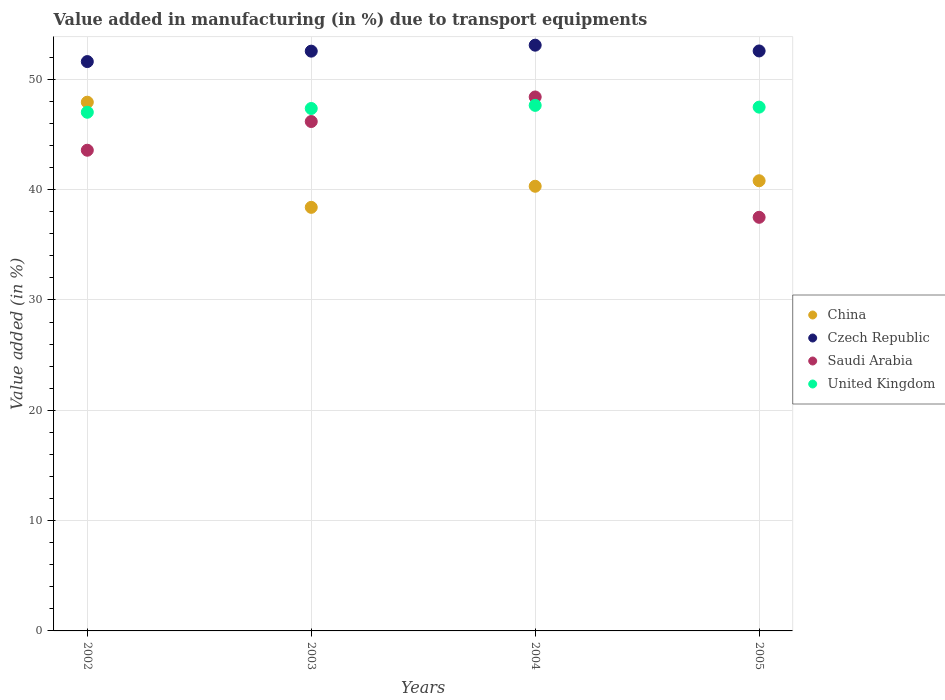How many different coloured dotlines are there?
Give a very brief answer. 4. Is the number of dotlines equal to the number of legend labels?
Offer a terse response. Yes. What is the percentage of value added in manufacturing due to transport equipments in China in 2005?
Ensure brevity in your answer.  40.81. Across all years, what is the maximum percentage of value added in manufacturing due to transport equipments in China?
Your answer should be very brief. 47.93. Across all years, what is the minimum percentage of value added in manufacturing due to transport equipments in Saudi Arabia?
Your response must be concise. 37.49. In which year was the percentage of value added in manufacturing due to transport equipments in Saudi Arabia minimum?
Give a very brief answer. 2005. What is the total percentage of value added in manufacturing due to transport equipments in Czech Republic in the graph?
Your response must be concise. 209.84. What is the difference between the percentage of value added in manufacturing due to transport equipments in Czech Republic in 2003 and that in 2005?
Keep it short and to the point. -0.02. What is the difference between the percentage of value added in manufacturing due to transport equipments in China in 2003 and the percentage of value added in manufacturing due to transport equipments in United Kingdom in 2005?
Give a very brief answer. -9.08. What is the average percentage of value added in manufacturing due to transport equipments in United Kingdom per year?
Keep it short and to the point. 47.37. In the year 2003, what is the difference between the percentage of value added in manufacturing due to transport equipments in United Kingdom and percentage of value added in manufacturing due to transport equipments in Saudi Arabia?
Give a very brief answer. 1.18. In how many years, is the percentage of value added in manufacturing due to transport equipments in Czech Republic greater than 32 %?
Offer a very short reply. 4. What is the ratio of the percentage of value added in manufacturing due to transport equipments in China in 2002 to that in 2005?
Offer a very short reply. 1.17. Is the difference between the percentage of value added in manufacturing due to transport equipments in United Kingdom in 2002 and 2005 greater than the difference between the percentage of value added in manufacturing due to transport equipments in Saudi Arabia in 2002 and 2005?
Provide a short and direct response. No. What is the difference between the highest and the second highest percentage of value added in manufacturing due to transport equipments in China?
Make the answer very short. 7.12. What is the difference between the highest and the lowest percentage of value added in manufacturing due to transport equipments in China?
Provide a succinct answer. 9.53. Is the sum of the percentage of value added in manufacturing due to transport equipments in China in 2004 and 2005 greater than the maximum percentage of value added in manufacturing due to transport equipments in United Kingdom across all years?
Make the answer very short. Yes. Does the percentage of value added in manufacturing due to transport equipments in China monotonically increase over the years?
Offer a very short reply. No. Is the percentage of value added in manufacturing due to transport equipments in China strictly less than the percentage of value added in manufacturing due to transport equipments in Czech Republic over the years?
Provide a short and direct response. Yes. How many years are there in the graph?
Offer a very short reply. 4. Does the graph contain any zero values?
Give a very brief answer. No. How many legend labels are there?
Make the answer very short. 4. How are the legend labels stacked?
Your response must be concise. Vertical. What is the title of the graph?
Make the answer very short. Value added in manufacturing (in %) due to transport equipments. Does "Seychelles" appear as one of the legend labels in the graph?
Your answer should be compact. No. What is the label or title of the Y-axis?
Provide a succinct answer. Value added (in %). What is the Value added (in %) of China in 2002?
Provide a short and direct response. 47.93. What is the Value added (in %) of Czech Republic in 2002?
Offer a terse response. 51.61. What is the Value added (in %) in Saudi Arabia in 2002?
Provide a succinct answer. 43.57. What is the Value added (in %) in United Kingdom in 2002?
Offer a very short reply. 47.02. What is the Value added (in %) in China in 2003?
Your response must be concise. 38.4. What is the Value added (in %) of Czech Republic in 2003?
Offer a terse response. 52.56. What is the Value added (in %) of Saudi Arabia in 2003?
Keep it short and to the point. 46.18. What is the Value added (in %) of United Kingdom in 2003?
Ensure brevity in your answer.  47.36. What is the Value added (in %) in China in 2004?
Your answer should be very brief. 40.31. What is the Value added (in %) in Czech Republic in 2004?
Ensure brevity in your answer.  53.1. What is the Value added (in %) of Saudi Arabia in 2004?
Offer a very short reply. 48.4. What is the Value added (in %) in United Kingdom in 2004?
Your answer should be very brief. 47.64. What is the Value added (in %) of China in 2005?
Your response must be concise. 40.81. What is the Value added (in %) of Czech Republic in 2005?
Ensure brevity in your answer.  52.57. What is the Value added (in %) of Saudi Arabia in 2005?
Offer a very short reply. 37.49. What is the Value added (in %) of United Kingdom in 2005?
Ensure brevity in your answer.  47.48. Across all years, what is the maximum Value added (in %) in China?
Provide a succinct answer. 47.93. Across all years, what is the maximum Value added (in %) in Czech Republic?
Provide a succinct answer. 53.1. Across all years, what is the maximum Value added (in %) in Saudi Arabia?
Provide a succinct answer. 48.4. Across all years, what is the maximum Value added (in %) of United Kingdom?
Keep it short and to the point. 47.64. Across all years, what is the minimum Value added (in %) in China?
Your answer should be compact. 38.4. Across all years, what is the minimum Value added (in %) of Czech Republic?
Give a very brief answer. 51.61. Across all years, what is the minimum Value added (in %) in Saudi Arabia?
Your response must be concise. 37.49. Across all years, what is the minimum Value added (in %) of United Kingdom?
Give a very brief answer. 47.02. What is the total Value added (in %) in China in the graph?
Offer a very short reply. 167.44. What is the total Value added (in %) in Czech Republic in the graph?
Provide a succinct answer. 209.84. What is the total Value added (in %) of Saudi Arabia in the graph?
Your answer should be very brief. 175.65. What is the total Value added (in %) in United Kingdom in the graph?
Your answer should be compact. 189.49. What is the difference between the Value added (in %) of China in 2002 and that in 2003?
Provide a succinct answer. 9.53. What is the difference between the Value added (in %) of Czech Republic in 2002 and that in 2003?
Your answer should be compact. -0.95. What is the difference between the Value added (in %) in Saudi Arabia in 2002 and that in 2003?
Make the answer very short. -2.6. What is the difference between the Value added (in %) in United Kingdom in 2002 and that in 2003?
Provide a succinct answer. -0.34. What is the difference between the Value added (in %) of China in 2002 and that in 2004?
Offer a terse response. 7.62. What is the difference between the Value added (in %) in Czech Republic in 2002 and that in 2004?
Your answer should be very brief. -1.49. What is the difference between the Value added (in %) in Saudi Arabia in 2002 and that in 2004?
Offer a terse response. -4.83. What is the difference between the Value added (in %) in United Kingdom in 2002 and that in 2004?
Provide a short and direct response. -0.62. What is the difference between the Value added (in %) of China in 2002 and that in 2005?
Provide a succinct answer. 7.12. What is the difference between the Value added (in %) of Czech Republic in 2002 and that in 2005?
Provide a short and direct response. -0.96. What is the difference between the Value added (in %) of Saudi Arabia in 2002 and that in 2005?
Provide a short and direct response. 6.08. What is the difference between the Value added (in %) of United Kingdom in 2002 and that in 2005?
Provide a succinct answer. -0.46. What is the difference between the Value added (in %) of China in 2003 and that in 2004?
Make the answer very short. -1.91. What is the difference between the Value added (in %) of Czech Republic in 2003 and that in 2004?
Provide a short and direct response. -0.54. What is the difference between the Value added (in %) in Saudi Arabia in 2003 and that in 2004?
Make the answer very short. -2.23. What is the difference between the Value added (in %) of United Kingdom in 2003 and that in 2004?
Provide a succinct answer. -0.28. What is the difference between the Value added (in %) in China in 2003 and that in 2005?
Provide a short and direct response. -2.41. What is the difference between the Value added (in %) in Czech Republic in 2003 and that in 2005?
Offer a terse response. -0.02. What is the difference between the Value added (in %) of Saudi Arabia in 2003 and that in 2005?
Ensure brevity in your answer.  8.68. What is the difference between the Value added (in %) in United Kingdom in 2003 and that in 2005?
Give a very brief answer. -0.12. What is the difference between the Value added (in %) in China in 2004 and that in 2005?
Ensure brevity in your answer.  -0.5. What is the difference between the Value added (in %) of Czech Republic in 2004 and that in 2005?
Your response must be concise. 0.52. What is the difference between the Value added (in %) in Saudi Arabia in 2004 and that in 2005?
Your answer should be very brief. 10.91. What is the difference between the Value added (in %) in United Kingdom in 2004 and that in 2005?
Your answer should be compact. 0.16. What is the difference between the Value added (in %) of China in 2002 and the Value added (in %) of Czech Republic in 2003?
Provide a succinct answer. -4.63. What is the difference between the Value added (in %) in China in 2002 and the Value added (in %) in Saudi Arabia in 2003?
Your response must be concise. 1.75. What is the difference between the Value added (in %) in China in 2002 and the Value added (in %) in United Kingdom in 2003?
Provide a short and direct response. 0.57. What is the difference between the Value added (in %) of Czech Republic in 2002 and the Value added (in %) of Saudi Arabia in 2003?
Offer a very short reply. 5.43. What is the difference between the Value added (in %) in Czech Republic in 2002 and the Value added (in %) in United Kingdom in 2003?
Ensure brevity in your answer.  4.25. What is the difference between the Value added (in %) in Saudi Arabia in 2002 and the Value added (in %) in United Kingdom in 2003?
Your response must be concise. -3.78. What is the difference between the Value added (in %) of China in 2002 and the Value added (in %) of Czech Republic in 2004?
Your answer should be compact. -5.17. What is the difference between the Value added (in %) in China in 2002 and the Value added (in %) in Saudi Arabia in 2004?
Provide a succinct answer. -0.47. What is the difference between the Value added (in %) in China in 2002 and the Value added (in %) in United Kingdom in 2004?
Your answer should be compact. 0.29. What is the difference between the Value added (in %) of Czech Republic in 2002 and the Value added (in %) of Saudi Arabia in 2004?
Make the answer very short. 3.21. What is the difference between the Value added (in %) in Czech Republic in 2002 and the Value added (in %) in United Kingdom in 2004?
Offer a very short reply. 3.97. What is the difference between the Value added (in %) of Saudi Arabia in 2002 and the Value added (in %) of United Kingdom in 2004?
Make the answer very short. -4.07. What is the difference between the Value added (in %) of China in 2002 and the Value added (in %) of Czech Republic in 2005?
Offer a terse response. -4.65. What is the difference between the Value added (in %) in China in 2002 and the Value added (in %) in Saudi Arabia in 2005?
Ensure brevity in your answer.  10.43. What is the difference between the Value added (in %) of China in 2002 and the Value added (in %) of United Kingdom in 2005?
Offer a very short reply. 0.45. What is the difference between the Value added (in %) in Czech Republic in 2002 and the Value added (in %) in Saudi Arabia in 2005?
Offer a very short reply. 14.12. What is the difference between the Value added (in %) of Czech Republic in 2002 and the Value added (in %) of United Kingdom in 2005?
Your answer should be very brief. 4.13. What is the difference between the Value added (in %) of Saudi Arabia in 2002 and the Value added (in %) of United Kingdom in 2005?
Give a very brief answer. -3.91. What is the difference between the Value added (in %) in China in 2003 and the Value added (in %) in Czech Republic in 2004?
Ensure brevity in your answer.  -14.7. What is the difference between the Value added (in %) of China in 2003 and the Value added (in %) of Saudi Arabia in 2004?
Offer a terse response. -10.01. What is the difference between the Value added (in %) of China in 2003 and the Value added (in %) of United Kingdom in 2004?
Give a very brief answer. -9.24. What is the difference between the Value added (in %) of Czech Republic in 2003 and the Value added (in %) of Saudi Arabia in 2004?
Provide a short and direct response. 4.15. What is the difference between the Value added (in %) in Czech Republic in 2003 and the Value added (in %) in United Kingdom in 2004?
Offer a very short reply. 4.92. What is the difference between the Value added (in %) in Saudi Arabia in 2003 and the Value added (in %) in United Kingdom in 2004?
Offer a very short reply. -1.46. What is the difference between the Value added (in %) of China in 2003 and the Value added (in %) of Czech Republic in 2005?
Offer a terse response. -14.18. What is the difference between the Value added (in %) in China in 2003 and the Value added (in %) in Saudi Arabia in 2005?
Provide a short and direct response. 0.9. What is the difference between the Value added (in %) in China in 2003 and the Value added (in %) in United Kingdom in 2005?
Provide a short and direct response. -9.08. What is the difference between the Value added (in %) of Czech Republic in 2003 and the Value added (in %) of Saudi Arabia in 2005?
Keep it short and to the point. 15.06. What is the difference between the Value added (in %) of Czech Republic in 2003 and the Value added (in %) of United Kingdom in 2005?
Your answer should be very brief. 5.08. What is the difference between the Value added (in %) of Saudi Arabia in 2003 and the Value added (in %) of United Kingdom in 2005?
Offer a terse response. -1.31. What is the difference between the Value added (in %) in China in 2004 and the Value added (in %) in Czech Republic in 2005?
Your answer should be very brief. -12.27. What is the difference between the Value added (in %) in China in 2004 and the Value added (in %) in Saudi Arabia in 2005?
Offer a terse response. 2.81. What is the difference between the Value added (in %) in China in 2004 and the Value added (in %) in United Kingdom in 2005?
Provide a short and direct response. -7.17. What is the difference between the Value added (in %) in Czech Republic in 2004 and the Value added (in %) in Saudi Arabia in 2005?
Ensure brevity in your answer.  15.6. What is the difference between the Value added (in %) in Czech Republic in 2004 and the Value added (in %) in United Kingdom in 2005?
Provide a short and direct response. 5.62. What is the difference between the Value added (in %) in Saudi Arabia in 2004 and the Value added (in %) in United Kingdom in 2005?
Your answer should be very brief. 0.92. What is the average Value added (in %) of China per year?
Ensure brevity in your answer.  41.86. What is the average Value added (in %) of Czech Republic per year?
Your answer should be compact. 52.46. What is the average Value added (in %) of Saudi Arabia per year?
Your response must be concise. 43.91. What is the average Value added (in %) in United Kingdom per year?
Offer a terse response. 47.37. In the year 2002, what is the difference between the Value added (in %) in China and Value added (in %) in Czech Republic?
Provide a succinct answer. -3.68. In the year 2002, what is the difference between the Value added (in %) in China and Value added (in %) in Saudi Arabia?
Make the answer very short. 4.35. In the year 2002, what is the difference between the Value added (in %) in China and Value added (in %) in United Kingdom?
Ensure brevity in your answer.  0.91. In the year 2002, what is the difference between the Value added (in %) of Czech Republic and Value added (in %) of Saudi Arabia?
Your response must be concise. 8.04. In the year 2002, what is the difference between the Value added (in %) in Czech Republic and Value added (in %) in United Kingdom?
Your answer should be compact. 4.59. In the year 2002, what is the difference between the Value added (in %) of Saudi Arabia and Value added (in %) of United Kingdom?
Offer a very short reply. -3.44. In the year 2003, what is the difference between the Value added (in %) of China and Value added (in %) of Czech Republic?
Your answer should be very brief. -14.16. In the year 2003, what is the difference between the Value added (in %) in China and Value added (in %) in Saudi Arabia?
Provide a short and direct response. -7.78. In the year 2003, what is the difference between the Value added (in %) in China and Value added (in %) in United Kingdom?
Keep it short and to the point. -8.96. In the year 2003, what is the difference between the Value added (in %) in Czech Republic and Value added (in %) in Saudi Arabia?
Offer a very short reply. 6.38. In the year 2003, what is the difference between the Value added (in %) in Czech Republic and Value added (in %) in United Kingdom?
Give a very brief answer. 5.2. In the year 2003, what is the difference between the Value added (in %) in Saudi Arabia and Value added (in %) in United Kingdom?
Your answer should be compact. -1.18. In the year 2004, what is the difference between the Value added (in %) in China and Value added (in %) in Czech Republic?
Your response must be concise. -12.79. In the year 2004, what is the difference between the Value added (in %) of China and Value added (in %) of Saudi Arabia?
Your answer should be compact. -8.09. In the year 2004, what is the difference between the Value added (in %) of China and Value added (in %) of United Kingdom?
Keep it short and to the point. -7.33. In the year 2004, what is the difference between the Value added (in %) in Czech Republic and Value added (in %) in Saudi Arabia?
Make the answer very short. 4.69. In the year 2004, what is the difference between the Value added (in %) in Czech Republic and Value added (in %) in United Kingdom?
Your response must be concise. 5.46. In the year 2004, what is the difference between the Value added (in %) in Saudi Arabia and Value added (in %) in United Kingdom?
Give a very brief answer. 0.76. In the year 2005, what is the difference between the Value added (in %) of China and Value added (in %) of Czech Republic?
Your answer should be very brief. -11.77. In the year 2005, what is the difference between the Value added (in %) in China and Value added (in %) in Saudi Arabia?
Provide a short and direct response. 3.31. In the year 2005, what is the difference between the Value added (in %) in China and Value added (in %) in United Kingdom?
Give a very brief answer. -6.67. In the year 2005, what is the difference between the Value added (in %) in Czech Republic and Value added (in %) in Saudi Arabia?
Offer a very short reply. 15.08. In the year 2005, what is the difference between the Value added (in %) in Czech Republic and Value added (in %) in United Kingdom?
Offer a very short reply. 5.09. In the year 2005, what is the difference between the Value added (in %) in Saudi Arabia and Value added (in %) in United Kingdom?
Your answer should be very brief. -9.99. What is the ratio of the Value added (in %) in China in 2002 to that in 2003?
Make the answer very short. 1.25. What is the ratio of the Value added (in %) of Saudi Arabia in 2002 to that in 2003?
Keep it short and to the point. 0.94. What is the ratio of the Value added (in %) in China in 2002 to that in 2004?
Provide a short and direct response. 1.19. What is the ratio of the Value added (in %) of Czech Republic in 2002 to that in 2004?
Make the answer very short. 0.97. What is the ratio of the Value added (in %) in Saudi Arabia in 2002 to that in 2004?
Make the answer very short. 0.9. What is the ratio of the Value added (in %) of United Kingdom in 2002 to that in 2004?
Your answer should be very brief. 0.99. What is the ratio of the Value added (in %) in China in 2002 to that in 2005?
Your answer should be compact. 1.17. What is the ratio of the Value added (in %) of Czech Republic in 2002 to that in 2005?
Give a very brief answer. 0.98. What is the ratio of the Value added (in %) in Saudi Arabia in 2002 to that in 2005?
Offer a very short reply. 1.16. What is the ratio of the Value added (in %) of United Kingdom in 2002 to that in 2005?
Provide a short and direct response. 0.99. What is the ratio of the Value added (in %) of China in 2003 to that in 2004?
Provide a succinct answer. 0.95. What is the ratio of the Value added (in %) of Saudi Arabia in 2003 to that in 2004?
Keep it short and to the point. 0.95. What is the ratio of the Value added (in %) of China in 2003 to that in 2005?
Make the answer very short. 0.94. What is the ratio of the Value added (in %) of Saudi Arabia in 2003 to that in 2005?
Make the answer very short. 1.23. What is the ratio of the Value added (in %) of United Kingdom in 2003 to that in 2005?
Your answer should be compact. 1. What is the ratio of the Value added (in %) in Saudi Arabia in 2004 to that in 2005?
Offer a very short reply. 1.29. What is the difference between the highest and the second highest Value added (in %) of China?
Your response must be concise. 7.12. What is the difference between the highest and the second highest Value added (in %) of Czech Republic?
Your answer should be very brief. 0.52. What is the difference between the highest and the second highest Value added (in %) in Saudi Arabia?
Ensure brevity in your answer.  2.23. What is the difference between the highest and the second highest Value added (in %) of United Kingdom?
Ensure brevity in your answer.  0.16. What is the difference between the highest and the lowest Value added (in %) in China?
Your response must be concise. 9.53. What is the difference between the highest and the lowest Value added (in %) in Czech Republic?
Keep it short and to the point. 1.49. What is the difference between the highest and the lowest Value added (in %) of Saudi Arabia?
Give a very brief answer. 10.91. What is the difference between the highest and the lowest Value added (in %) in United Kingdom?
Keep it short and to the point. 0.62. 